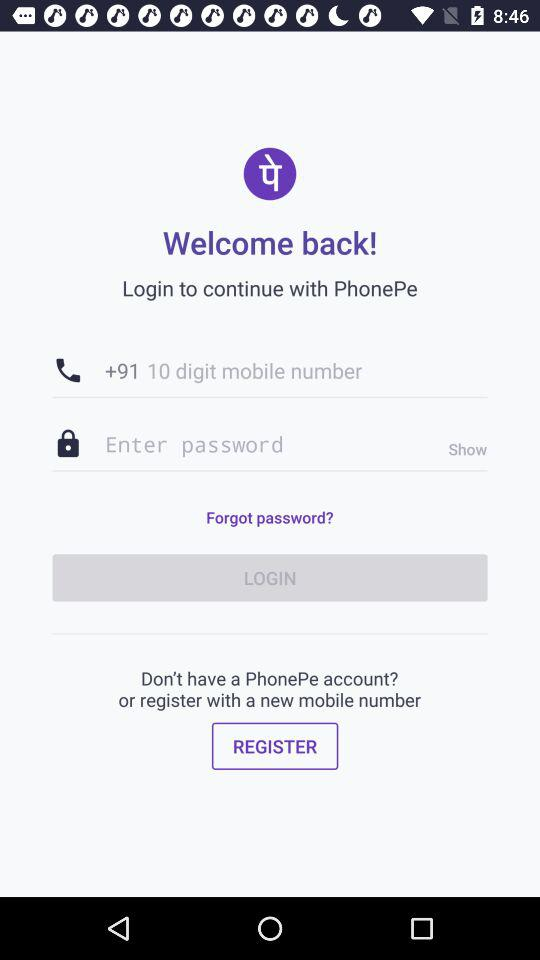What are the requirements to log in? The requirements to log in are a 10-digit mobile number and a password. 